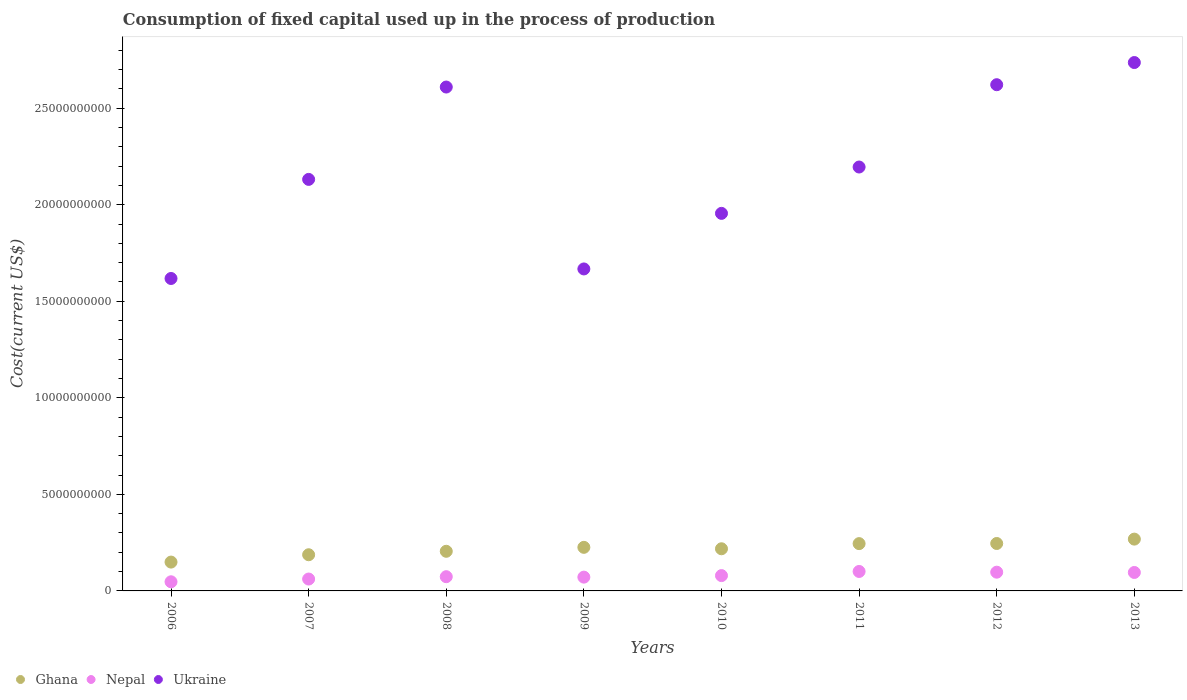What is the amount consumed in the process of production in Nepal in 2012?
Ensure brevity in your answer.  9.70e+08. Across all years, what is the maximum amount consumed in the process of production in Ukraine?
Keep it short and to the point. 2.74e+1. Across all years, what is the minimum amount consumed in the process of production in Nepal?
Keep it short and to the point. 4.73e+08. In which year was the amount consumed in the process of production in Ghana maximum?
Give a very brief answer. 2013. What is the total amount consumed in the process of production in Ghana in the graph?
Offer a very short reply. 1.74e+1. What is the difference between the amount consumed in the process of production in Ghana in 2006 and that in 2009?
Provide a short and direct response. -7.63e+08. What is the difference between the amount consumed in the process of production in Ghana in 2009 and the amount consumed in the process of production in Nepal in 2010?
Provide a short and direct response. 1.46e+09. What is the average amount consumed in the process of production in Ukraine per year?
Ensure brevity in your answer.  2.19e+1. In the year 2006, what is the difference between the amount consumed in the process of production in Ukraine and amount consumed in the process of production in Ghana?
Offer a terse response. 1.47e+1. In how many years, is the amount consumed in the process of production in Ukraine greater than 27000000000 US$?
Offer a very short reply. 1. What is the ratio of the amount consumed in the process of production in Nepal in 2007 to that in 2010?
Your answer should be compact. 0.78. What is the difference between the highest and the second highest amount consumed in the process of production in Ukraine?
Your answer should be very brief. 1.15e+09. What is the difference between the highest and the lowest amount consumed in the process of production in Nepal?
Offer a very short reply. 5.35e+08. In how many years, is the amount consumed in the process of production in Ukraine greater than the average amount consumed in the process of production in Ukraine taken over all years?
Your response must be concise. 4. Is the sum of the amount consumed in the process of production in Nepal in 2008 and 2010 greater than the maximum amount consumed in the process of production in Ukraine across all years?
Your answer should be compact. No. Is it the case that in every year, the sum of the amount consumed in the process of production in Ghana and amount consumed in the process of production in Nepal  is greater than the amount consumed in the process of production in Ukraine?
Your answer should be compact. No. Is the amount consumed in the process of production in Ghana strictly less than the amount consumed in the process of production in Ukraine over the years?
Provide a short and direct response. Yes. How many years are there in the graph?
Provide a succinct answer. 8. Does the graph contain grids?
Give a very brief answer. No. How are the legend labels stacked?
Your answer should be very brief. Horizontal. What is the title of the graph?
Your answer should be compact. Consumption of fixed capital used up in the process of production. What is the label or title of the X-axis?
Make the answer very short. Years. What is the label or title of the Y-axis?
Offer a very short reply. Cost(current US$). What is the Cost(current US$) of Ghana in 2006?
Provide a succinct answer. 1.49e+09. What is the Cost(current US$) of Nepal in 2006?
Keep it short and to the point. 4.73e+08. What is the Cost(current US$) of Ukraine in 2006?
Offer a very short reply. 1.62e+1. What is the Cost(current US$) in Ghana in 2007?
Your response must be concise. 1.87e+09. What is the Cost(current US$) in Nepal in 2007?
Keep it short and to the point. 6.16e+08. What is the Cost(current US$) in Ukraine in 2007?
Your response must be concise. 2.13e+1. What is the Cost(current US$) in Ghana in 2008?
Your response must be concise. 2.05e+09. What is the Cost(current US$) in Nepal in 2008?
Make the answer very short. 7.37e+08. What is the Cost(current US$) of Ukraine in 2008?
Give a very brief answer. 2.61e+1. What is the Cost(current US$) of Ghana in 2009?
Offer a very short reply. 2.26e+09. What is the Cost(current US$) in Nepal in 2009?
Provide a short and direct response. 7.14e+08. What is the Cost(current US$) of Ukraine in 2009?
Ensure brevity in your answer.  1.67e+1. What is the Cost(current US$) in Ghana in 2010?
Keep it short and to the point. 2.18e+09. What is the Cost(current US$) of Nepal in 2010?
Keep it short and to the point. 7.93e+08. What is the Cost(current US$) in Ukraine in 2010?
Ensure brevity in your answer.  1.96e+1. What is the Cost(current US$) of Ghana in 2011?
Give a very brief answer. 2.45e+09. What is the Cost(current US$) of Nepal in 2011?
Your response must be concise. 1.01e+09. What is the Cost(current US$) of Ukraine in 2011?
Offer a very short reply. 2.20e+1. What is the Cost(current US$) in Ghana in 2012?
Provide a succinct answer. 2.46e+09. What is the Cost(current US$) of Nepal in 2012?
Your answer should be very brief. 9.70e+08. What is the Cost(current US$) in Ukraine in 2012?
Make the answer very short. 2.62e+1. What is the Cost(current US$) of Ghana in 2013?
Give a very brief answer. 2.68e+09. What is the Cost(current US$) in Nepal in 2013?
Your answer should be very brief. 9.56e+08. What is the Cost(current US$) in Ukraine in 2013?
Provide a short and direct response. 2.74e+1. Across all years, what is the maximum Cost(current US$) in Ghana?
Provide a short and direct response. 2.68e+09. Across all years, what is the maximum Cost(current US$) in Nepal?
Ensure brevity in your answer.  1.01e+09. Across all years, what is the maximum Cost(current US$) of Ukraine?
Offer a very short reply. 2.74e+1. Across all years, what is the minimum Cost(current US$) of Ghana?
Offer a terse response. 1.49e+09. Across all years, what is the minimum Cost(current US$) of Nepal?
Make the answer very short. 4.73e+08. Across all years, what is the minimum Cost(current US$) of Ukraine?
Provide a short and direct response. 1.62e+1. What is the total Cost(current US$) in Ghana in the graph?
Make the answer very short. 1.74e+1. What is the total Cost(current US$) in Nepal in the graph?
Give a very brief answer. 6.27e+09. What is the total Cost(current US$) in Ukraine in the graph?
Provide a succinct answer. 1.75e+11. What is the difference between the Cost(current US$) of Ghana in 2006 and that in 2007?
Keep it short and to the point. -3.80e+08. What is the difference between the Cost(current US$) in Nepal in 2006 and that in 2007?
Make the answer very short. -1.43e+08. What is the difference between the Cost(current US$) of Ukraine in 2006 and that in 2007?
Your answer should be compact. -5.13e+09. What is the difference between the Cost(current US$) in Ghana in 2006 and that in 2008?
Ensure brevity in your answer.  -5.59e+08. What is the difference between the Cost(current US$) in Nepal in 2006 and that in 2008?
Your response must be concise. -2.64e+08. What is the difference between the Cost(current US$) of Ukraine in 2006 and that in 2008?
Your answer should be very brief. -9.91e+09. What is the difference between the Cost(current US$) of Ghana in 2006 and that in 2009?
Offer a very short reply. -7.63e+08. What is the difference between the Cost(current US$) of Nepal in 2006 and that in 2009?
Give a very brief answer. -2.41e+08. What is the difference between the Cost(current US$) in Ukraine in 2006 and that in 2009?
Offer a very short reply. -4.94e+08. What is the difference between the Cost(current US$) of Ghana in 2006 and that in 2010?
Provide a short and direct response. -6.89e+08. What is the difference between the Cost(current US$) in Nepal in 2006 and that in 2010?
Your answer should be very brief. -3.20e+08. What is the difference between the Cost(current US$) in Ukraine in 2006 and that in 2010?
Offer a very short reply. -3.37e+09. What is the difference between the Cost(current US$) of Ghana in 2006 and that in 2011?
Your answer should be very brief. -9.56e+08. What is the difference between the Cost(current US$) in Nepal in 2006 and that in 2011?
Give a very brief answer. -5.35e+08. What is the difference between the Cost(current US$) of Ukraine in 2006 and that in 2011?
Give a very brief answer. -5.77e+09. What is the difference between the Cost(current US$) in Ghana in 2006 and that in 2012?
Provide a succinct answer. -9.63e+08. What is the difference between the Cost(current US$) in Nepal in 2006 and that in 2012?
Offer a terse response. -4.97e+08. What is the difference between the Cost(current US$) in Ukraine in 2006 and that in 2012?
Offer a very short reply. -1.00e+1. What is the difference between the Cost(current US$) in Ghana in 2006 and that in 2013?
Give a very brief answer. -1.19e+09. What is the difference between the Cost(current US$) of Nepal in 2006 and that in 2013?
Keep it short and to the point. -4.83e+08. What is the difference between the Cost(current US$) in Ukraine in 2006 and that in 2013?
Make the answer very short. -1.12e+1. What is the difference between the Cost(current US$) of Ghana in 2007 and that in 2008?
Your answer should be compact. -1.79e+08. What is the difference between the Cost(current US$) in Nepal in 2007 and that in 2008?
Keep it short and to the point. -1.21e+08. What is the difference between the Cost(current US$) in Ukraine in 2007 and that in 2008?
Your response must be concise. -4.78e+09. What is the difference between the Cost(current US$) in Ghana in 2007 and that in 2009?
Make the answer very short. -3.84e+08. What is the difference between the Cost(current US$) of Nepal in 2007 and that in 2009?
Your answer should be very brief. -9.81e+07. What is the difference between the Cost(current US$) in Ukraine in 2007 and that in 2009?
Offer a terse response. 4.64e+09. What is the difference between the Cost(current US$) in Ghana in 2007 and that in 2010?
Your response must be concise. -3.09e+08. What is the difference between the Cost(current US$) of Nepal in 2007 and that in 2010?
Provide a short and direct response. -1.78e+08. What is the difference between the Cost(current US$) in Ukraine in 2007 and that in 2010?
Your response must be concise. 1.76e+09. What is the difference between the Cost(current US$) in Ghana in 2007 and that in 2011?
Offer a terse response. -5.76e+08. What is the difference between the Cost(current US$) in Nepal in 2007 and that in 2011?
Offer a very short reply. -3.92e+08. What is the difference between the Cost(current US$) of Ukraine in 2007 and that in 2011?
Ensure brevity in your answer.  -6.41e+08. What is the difference between the Cost(current US$) of Ghana in 2007 and that in 2012?
Keep it short and to the point. -5.83e+08. What is the difference between the Cost(current US$) in Nepal in 2007 and that in 2012?
Offer a terse response. -3.55e+08. What is the difference between the Cost(current US$) in Ukraine in 2007 and that in 2012?
Your response must be concise. -4.90e+09. What is the difference between the Cost(current US$) of Ghana in 2007 and that in 2013?
Offer a terse response. -8.10e+08. What is the difference between the Cost(current US$) in Nepal in 2007 and that in 2013?
Keep it short and to the point. -3.40e+08. What is the difference between the Cost(current US$) in Ukraine in 2007 and that in 2013?
Keep it short and to the point. -6.05e+09. What is the difference between the Cost(current US$) of Ghana in 2008 and that in 2009?
Offer a terse response. -2.05e+08. What is the difference between the Cost(current US$) of Nepal in 2008 and that in 2009?
Provide a succinct answer. 2.30e+07. What is the difference between the Cost(current US$) of Ukraine in 2008 and that in 2009?
Offer a terse response. 9.42e+09. What is the difference between the Cost(current US$) of Ghana in 2008 and that in 2010?
Offer a very short reply. -1.30e+08. What is the difference between the Cost(current US$) in Nepal in 2008 and that in 2010?
Offer a terse response. -5.67e+07. What is the difference between the Cost(current US$) of Ukraine in 2008 and that in 2010?
Offer a terse response. 6.54e+09. What is the difference between the Cost(current US$) of Ghana in 2008 and that in 2011?
Give a very brief answer. -3.97e+08. What is the difference between the Cost(current US$) of Nepal in 2008 and that in 2011?
Give a very brief answer. -2.71e+08. What is the difference between the Cost(current US$) of Ukraine in 2008 and that in 2011?
Provide a short and direct response. 4.14e+09. What is the difference between the Cost(current US$) in Ghana in 2008 and that in 2012?
Offer a terse response. -4.04e+08. What is the difference between the Cost(current US$) in Nepal in 2008 and that in 2012?
Provide a succinct answer. -2.34e+08. What is the difference between the Cost(current US$) of Ukraine in 2008 and that in 2012?
Offer a terse response. -1.21e+08. What is the difference between the Cost(current US$) in Ghana in 2008 and that in 2013?
Offer a terse response. -6.31e+08. What is the difference between the Cost(current US$) in Nepal in 2008 and that in 2013?
Provide a succinct answer. -2.19e+08. What is the difference between the Cost(current US$) of Ukraine in 2008 and that in 2013?
Your answer should be very brief. -1.27e+09. What is the difference between the Cost(current US$) of Ghana in 2009 and that in 2010?
Your answer should be very brief. 7.44e+07. What is the difference between the Cost(current US$) of Nepal in 2009 and that in 2010?
Keep it short and to the point. -7.97e+07. What is the difference between the Cost(current US$) in Ukraine in 2009 and that in 2010?
Your answer should be compact. -2.88e+09. What is the difference between the Cost(current US$) of Ghana in 2009 and that in 2011?
Your answer should be very brief. -1.93e+08. What is the difference between the Cost(current US$) in Nepal in 2009 and that in 2011?
Give a very brief answer. -2.94e+08. What is the difference between the Cost(current US$) in Ukraine in 2009 and that in 2011?
Offer a very short reply. -5.28e+09. What is the difference between the Cost(current US$) in Ghana in 2009 and that in 2012?
Your answer should be compact. -1.99e+08. What is the difference between the Cost(current US$) in Nepal in 2009 and that in 2012?
Offer a terse response. -2.57e+08. What is the difference between the Cost(current US$) of Ukraine in 2009 and that in 2012?
Your answer should be very brief. -9.54e+09. What is the difference between the Cost(current US$) in Ghana in 2009 and that in 2013?
Your response must be concise. -4.26e+08. What is the difference between the Cost(current US$) in Nepal in 2009 and that in 2013?
Keep it short and to the point. -2.42e+08. What is the difference between the Cost(current US$) in Ukraine in 2009 and that in 2013?
Make the answer very short. -1.07e+1. What is the difference between the Cost(current US$) in Ghana in 2010 and that in 2011?
Your answer should be compact. -2.67e+08. What is the difference between the Cost(current US$) in Nepal in 2010 and that in 2011?
Make the answer very short. -2.14e+08. What is the difference between the Cost(current US$) in Ukraine in 2010 and that in 2011?
Provide a short and direct response. -2.40e+09. What is the difference between the Cost(current US$) of Ghana in 2010 and that in 2012?
Make the answer very short. -2.74e+08. What is the difference between the Cost(current US$) of Nepal in 2010 and that in 2012?
Give a very brief answer. -1.77e+08. What is the difference between the Cost(current US$) of Ukraine in 2010 and that in 2012?
Your response must be concise. -6.66e+09. What is the difference between the Cost(current US$) of Ghana in 2010 and that in 2013?
Provide a succinct answer. -5.00e+08. What is the difference between the Cost(current US$) of Nepal in 2010 and that in 2013?
Provide a succinct answer. -1.62e+08. What is the difference between the Cost(current US$) of Ukraine in 2010 and that in 2013?
Keep it short and to the point. -7.81e+09. What is the difference between the Cost(current US$) in Ghana in 2011 and that in 2012?
Give a very brief answer. -6.71e+06. What is the difference between the Cost(current US$) of Nepal in 2011 and that in 2012?
Offer a terse response. 3.75e+07. What is the difference between the Cost(current US$) in Ukraine in 2011 and that in 2012?
Offer a terse response. -4.26e+09. What is the difference between the Cost(current US$) of Ghana in 2011 and that in 2013?
Provide a short and direct response. -2.33e+08. What is the difference between the Cost(current US$) of Nepal in 2011 and that in 2013?
Keep it short and to the point. 5.21e+07. What is the difference between the Cost(current US$) in Ukraine in 2011 and that in 2013?
Provide a succinct answer. -5.41e+09. What is the difference between the Cost(current US$) in Ghana in 2012 and that in 2013?
Offer a terse response. -2.27e+08. What is the difference between the Cost(current US$) of Nepal in 2012 and that in 2013?
Your answer should be very brief. 1.47e+07. What is the difference between the Cost(current US$) of Ukraine in 2012 and that in 2013?
Ensure brevity in your answer.  -1.15e+09. What is the difference between the Cost(current US$) of Ghana in 2006 and the Cost(current US$) of Nepal in 2007?
Provide a short and direct response. 8.78e+08. What is the difference between the Cost(current US$) of Ghana in 2006 and the Cost(current US$) of Ukraine in 2007?
Provide a succinct answer. -1.98e+1. What is the difference between the Cost(current US$) of Nepal in 2006 and the Cost(current US$) of Ukraine in 2007?
Ensure brevity in your answer.  -2.08e+1. What is the difference between the Cost(current US$) of Ghana in 2006 and the Cost(current US$) of Nepal in 2008?
Provide a succinct answer. 7.57e+08. What is the difference between the Cost(current US$) of Ghana in 2006 and the Cost(current US$) of Ukraine in 2008?
Make the answer very short. -2.46e+1. What is the difference between the Cost(current US$) of Nepal in 2006 and the Cost(current US$) of Ukraine in 2008?
Offer a terse response. -2.56e+1. What is the difference between the Cost(current US$) of Ghana in 2006 and the Cost(current US$) of Nepal in 2009?
Offer a terse response. 7.80e+08. What is the difference between the Cost(current US$) in Ghana in 2006 and the Cost(current US$) in Ukraine in 2009?
Keep it short and to the point. -1.52e+1. What is the difference between the Cost(current US$) in Nepal in 2006 and the Cost(current US$) in Ukraine in 2009?
Keep it short and to the point. -1.62e+1. What is the difference between the Cost(current US$) of Ghana in 2006 and the Cost(current US$) of Nepal in 2010?
Provide a succinct answer. 7.00e+08. What is the difference between the Cost(current US$) of Ghana in 2006 and the Cost(current US$) of Ukraine in 2010?
Provide a short and direct response. -1.81e+1. What is the difference between the Cost(current US$) of Nepal in 2006 and the Cost(current US$) of Ukraine in 2010?
Your answer should be compact. -1.91e+1. What is the difference between the Cost(current US$) in Ghana in 2006 and the Cost(current US$) in Nepal in 2011?
Provide a short and direct response. 4.86e+08. What is the difference between the Cost(current US$) in Ghana in 2006 and the Cost(current US$) in Ukraine in 2011?
Keep it short and to the point. -2.05e+1. What is the difference between the Cost(current US$) in Nepal in 2006 and the Cost(current US$) in Ukraine in 2011?
Provide a succinct answer. -2.15e+1. What is the difference between the Cost(current US$) of Ghana in 2006 and the Cost(current US$) of Nepal in 2012?
Give a very brief answer. 5.23e+08. What is the difference between the Cost(current US$) in Ghana in 2006 and the Cost(current US$) in Ukraine in 2012?
Give a very brief answer. -2.47e+1. What is the difference between the Cost(current US$) of Nepal in 2006 and the Cost(current US$) of Ukraine in 2012?
Keep it short and to the point. -2.57e+1. What is the difference between the Cost(current US$) of Ghana in 2006 and the Cost(current US$) of Nepal in 2013?
Make the answer very short. 5.38e+08. What is the difference between the Cost(current US$) in Ghana in 2006 and the Cost(current US$) in Ukraine in 2013?
Your answer should be very brief. -2.59e+1. What is the difference between the Cost(current US$) in Nepal in 2006 and the Cost(current US$) in Ukraine in 2013?
Keep it short and to the point. -2.69e+1. What is the difference between the Cost(current US$) in Ghana in 2007 and the Cost(current US$) in Nepal in 2008?
Ensure brevity in your answer.  1.14e+09. What is the difference between the Cost(current US$) in Ghana in 2007 and the Cost(current US$) in Ukraine in 2008?
Give a very brief answer. -2.42e+1. What is the difference between the Cost(current US$) of Nepal in 2007 and the Cost(current US$) of Ukraine in 2008?
Your answer should be very brief. -2.55e+1. What is the difference between the Cost(current US$) of Ghana in 2007 and the Cost(current US$) of Nepal in 2009?
Offer a terse response. 1.16e+09. What is the difference between the Cost(current US$) of Ghana in 2007 and the Cost(current US$) of Ukraine in 2009?
Provide a short and direct response. -1.48e+1. What is the difference between the Cost(current US$) of Nepal in 2007 and the Cost(current US$) of Ukraine in 2009?
Give a very brief answer. -1.61e+1. What is the difference between the Cost(current US$) in Ghana in 2007 and the Cost(current US$) in Nepal in 2010?
Your answer should be very brief. 1.08e+09. What is the difference between the Cost(current US$) in Ghana in 2007 and the Cost(current US$) in Ukraine in 2010?
Provide a succinct answer. -1.77e+1. What is the difference between the Cost(current US$) in Nepal in 2007 and the Cost(current US$) in Ukraine in 2010?
Provide a short and direct response. -1.89e+1. What is the difference between the Cost(current US$) in Ghana in 2007 and the Cost(current US$) in Nepal in 2011?
Your answer should be compact. 8.65e+08. What is the difference between the Cost(current US$) of Ghana in 2007 and the Cost(current US$) of Ukraine in 2011?
Provide a short and direct response. -2.01e+1. What is the difference between the Cost(current US$) in Nepal in 2007 and the Cost(current US$) in Ukraine in 2011?
Provide a short and direct response. -2.13e+1. What is the difference between the Cost(current US$) in Ghana in 2007 and the Cost(current US$) in Nepal in 2012?
Your response must be concise. 9.03e+08. What is the difference between the Cost(current US$) in Ghana in 2007 and the Cost(current US$) in Ukraine in 2012?
Make the answer very short. -2.43e+1. What is the difference between the Cost(current US$) in Nepal in 2007 and the Cost(current US$) in Ukraine in 2012?
Ensure brevity in your answer.  -2.56e+1. What is the difference between the Cost(current US$) of Ghana in 2007 and the Cost(current US$) of Nepal in 2013?
Provide a succinct answer. 9.18e+08. What is the difference between the Cost(current US$) in Ghana in 2007 and the Cost(current US$) in Ukraine in 2013?
Provide a succinct answer. -2.55e+1. What is the difference between the Cost(current US$) in Nepal in 2007 and the Cost(current US$) in Ukraine in 2013?
Keep it short and to the point. -2.67e+1. What is the difference between the Cost(current US$) of Ghana in 2008 and the Cost(current US$) of Nepal in 2009?
Provide a short and direct response. 1.34e+09. What is the difference between the Cost(current US$) in Ghana in 2008 and the Cost(current US$) in Ukraine in 2009?
Your response must be concise. -1.46e+1. What is the difference between the Cost(current US$) in Nepal in 2008 and the Cost(current US$) in Ukraine in 2009?
Make the answer very short. -1.59e+1. What is the difference between the Cost(current US$) of Ghana in 2008 and the Cost(current US$) of Nepal in 2010?
Give a very brief answer. 1.26e+09. What is the difference between the Cost(current US$) in Ghana in 2008 and the Cost(current US$) in Ukraine in 2010?
Keep it short and to the point. -1.75e+1. What is the difference between the Cost(current US$) in Nepal in 2008 and the Cost(current US$) in Ukraine in 2010?
Keep it short and to the point. -1.88e+1. What is the difference between the Cost(current US$) of Ghana in 2008 and the Cost(current US$) of Nepal in 2011?
Offer a terse response. 1.04e+09. What is the difference between the Cost(current US$) in Ghana in 2008 and the Cost(current US$) in Ukraine in 2011?
Ensure brevity in your answer.  -1.99e+1. What is the difference between the Cost(current US$) in Nepal in 2008 and the Cost(current US$) in Ukraine in 2011?
Provide a short and direct response. -2.12e+1. What is the difference between the Cost(current US$) in Ghana in 2008 and the Cost(current US$) in Nepal in 2012?
Your answer should be very brief. 1.08e+09. What is the difference between the Cost(current US$) in Ghana in 2008 and the Cost(current US$) in Ukraine in 2012?
Give a very brief answer. -2.42e+1. What is the difference between the Cost(current US$) of Nepal in 2008 and the Cost(current US$) of Ukraine in 2012?
Provide a short and direct response. -2.55e+1. What is the difference between the Cost(current US$) in Ghana in 2008 and the Cost(current US$) in Nepal in 2013?
Make the answer very short. 1.10e+09. What is the difference between the Cost(current US$) of Ghana in 2008 and the Cost(current US$) of Ukraine in 2013?
Offer a terse response. -2.53e+1. What is the difference between the Cost(current US$) in Nepal in 2008 and the Cost(current US$) in Ukraine in 2013?
Your answer should be very brief. -2.66e+1. What is the difference between the Cost(current US$) in Ghana in 2009 and the Cost(current US$) in Nepal in 2010?
Offer a terse response. 1.46e+09. What is the difference between the Cost(current US$) in Ghana in 2009 and the Cost(current US$) in Ukraine in 2010?
Your answer should be compact. -1.73e+1. What is the difference between the Cost(current US$) in Nepal in 2009 and the Cost(current US$) in Ukraine in 2010?
Keep it short and to the point. -1.88e+1. What is the difference between the Cost(current US$) in Ghana in 2009 and the Cost(current US$) in Nepal in 2011?
Provide a succinct answer. 1.25e+09. What is the difference between the Cost(current US$) in Ghana in 2009 and the Cost(current US$) in Ukraine in 2011?
Keep it short and to the point. -1.97e+1. What is the difference between the Cost(current US$) of Nepal in 2009 and the Cost(current US$) of Ukraine in 2011?
Provide a short and direct response. -2.12e+1. What is the difference between the Cost(current US$) in Ghana in 2009 and the Cost(current US$) in Nepal in 2012?
Give a very brief answer. 1.29e+09. What is the difference between the Cost(current US$) of Ghana in 2009 and the Cost(current US$) of Ukraine in 2012?
Offer a very short reply. -2.40e+1. What is the difference between the Cost(current US$) of Nepal in 2009 and the Cost(current US$) of Ukraine in 2012?
Provide a succinct answer. -2.55e+1. What is the difference between the Cost(current US$) in Ghana in 2009 and the Cost(current US$) in Nepal in 2013?
Your response must be concise. 1.30e+09. What is the difference between the Cost(current US$) in Ghana in 2009 and the Cost(current US$) in Ukraine in 2013?
Offer a terse response. -2.51e+1. What is the difference between the Cost(current US$) in Nepal in 2009 and the Cost(current US$) in Ukraine in 2013?
Ensure brevity in your answer.  -2.66e+1. What is the difference between the Cost(current US$) of Ghana in 2010 and the Cost(current US$) of Nepal in 2011?
Make the answer very short. 1.17e+09. What is the difference between the Cost(current US$) of Ghana in 2010 and the Cost(current US$) of Ukraine in 2011?
Your answer should be very brief. -1.98e+1. What is the difference between the Cost(current US$) in Nepal in 2010 and the Cost(current US$) in Ukraine in 2011?
Offer a very short reply. -2.12e+1. What is the difference between the Cost(current US$) in Ghana in 2010 and the Cost(current US$) in Nepal in 2012?
Give a very brief answer. 1.21e+09. What is the difference between the Cost(current US$) in Ghana in 2010 and the Cost(current US$) in Ukraine in 2012?
Offer a terse response. -2.40e+1. What is the difference between the Cost(current US$) in Nepal in 2010 and the Cost(current US$) in Ukraine in 2012?
Offer a terse response. -2.54e+1. What is the difference between the Cost(current US$) in Ghana in 2010 and the Cost(current US$) in Nepal in 2013?
Give a very brief answer. 1.23e+09. What is the difference between the Cost(current US$) in Ghana in 2010 and the Cost(current US$) in Ukraine in 2013?
Offer a terse response. -2.52e+1. What is the difference between the Cost(current US$) in Nepal in 2010 and the Cost(current US$) in Ukraine in 2013?
Your answer should be very brief. -2.66e+1. What is the difference between the Cost(current US$) in Ghana in 2011 and the Cost(current US$) in Nepal in 2012?
Provide a succinct answer. 1.48e+09. What is the difference between the Cost(current US$) in Ghana in 2011 and the Cost(current US$) in Ukraine in 2012?
Provide a succinct answer. -2.38e+1. What is the difference between the Cost(current US$) in Nepal in 2011 and the Cost(current US$) in Ukraine in 2012?
Ensure brevity in your answer.  -2.52e+1. What is the difference between the Cost(current US$) of Ghana in 2011 and the Cost(current US$) of Nepal in 2013?
Your answer should be compact. 1.49e+09. What is the difference between the Cost(current US$) in Ghana in 2011 and the Cost(current US$) in Ukraine in 2013?
Offer a terse response. -2.49e+1. What is the difference between the Cost(current US$) in Nepal in 2011 and the Cost(current US$) in Ukraine in 2013?
Your answer should be very brief. -2.64e+1. What is the difference between the Cost(current US$) in Ghana in 2012 and the Cost(current US$) in Nepal in 2013?
Your answer should be compact. 1.50e+09. What is the difference between the Cost(current US$) in Ghana in 2012 and the Cost(current US$) in Ukraine in 2013?
Provide a succinct answer. -2.49e+1. What is the difference between the Cost(current US$) of Nepal in 2012 and the Cost(current US$) of Ukraine in 2013?
Your response must be concise. -2.64e+1. What is the average Cost(current US$) in Ghana per year?
Your answer should be compact. 2.18e+09. What is the average Cost(current US$) in Nepal per year?
Ensure brevity in your answer.  7.83e+08. What is the average Cost(current US$) of Ukraine per year?
Keep it short and to the point. 2.19e+1. In the year 2006, what is the difference between the Cost(current US$) of Ghana and Cost(current US$) of Nepal?
Keep it short and to the point. 1.02e+09. In the year 2006, what is the difference between the Cost(current US$) in Ghana and Cost(current US$) in Ukraine?
Your response must be concise. -1.47e+1. In the year 2006, what is the difference between the Cost(current US$) of Nepal and Cost(current US$) of Ukraine?
Offer a very short reply. -1.57e+1. In the year 2007, what is the difference between the Cost(current US$) of Ghana and Cost(current US$) of Nepal?
Your answer should be compact. 1.26e+09. In the year 2007, what is the difference between the Cost(current US$) in Ghana and Cost(current US$) in Ukraine?
Keep it short and to the point. -1.94e+1. In the year 2007, what is the difference between the Cost(current US$) of Nepal and Cost(current US$) of Ukraine?
Keep it short and to the point. -2.07e+1. In the year 2008, what is the difference between the Cost(current US$) in Ghana and Cost(current US$) in Nepal?
Give a very brief answer. 1.32e+09. In the year 2008, what is the difference between the Cost(current US$) of Ghana and Cost(current US$) of Ukraine?
Provide a succinct answer. -2.40e+1. In the year 2008, what is the difference between the Cost(current US$) of Nepal and Cost(current US$) of Ukraine?
Make the answer very short. -2.54e+1. In the year 2009, what is the difference between the Cost(current US$) in Ghana and Cost(current US$) in Nepal?
Provide a succinct answer. 1.54e+09. In the year 2009, what is the difference between the Cost(current US$) in Ghana and Cost(current US$) in Ukraine?
Make the answer very short. -1.44e+1. In the year 2009, what is the difference between the Cost(current US$) of Nepal and Cost(current US$) of Ukraine?
Give a very brief answer. -1.60e+1. In the year 2010, what is the difference between the Cost(current US$) in Ghana and Cost(current US$) in Nepal?
Your response must be concise. 1.39e+09. In the year 2010, what is the difference between the Cost(current US$) of Ghana and Cost(current US$) of Ukraine?
Provide a succinct answer. -1.74e+1. In the year 2010, what is the difference between the Cost(current US$) in Nepal and Cost(current US$) in Ukraine?
Your response must be concise. -1.88e+1. In the year 2011, what is the difference between the Cost(current US$) of Ghana and Cost(current US$) of Nepal?
Offer a very short reply. 1.44e+09. In the year 2011, what is the difference between the Cost(current US$) in Ghana and Cost(current US$) in Ukraine?
Keep it short and to the point. -1.95e+1. In the year 2011, what is the difference between the Cost(current US$) in Nepal and Cost(current US$) in Ukraine?
Give a very brief answer. -2.09e+1. In the year 2012, what is the difference between the Cost(current US$) of Ghana and Cost(current US$) of Nepal?
Offer a very short reply. 1.49e+09. In the year 2012, what is the difference between the Cost(current US$) of Ghana and Cost(current US$) of Ukraine?
Your response must be concise. -2.38e+1. In the year 2012, what is the difference between the Cost(current US$) in Nepal and Cost(current US$) in Ukraine?
Provide a short and direct response. -2.52e+1. In the year 2013, what is the difference between the Cost(current US$) of Ghana and Cost(current US$) of Nepal?
Give a very brief answer. 1.73e+09. In the year 2013, what is the difference between the Cost(current US$) of Ghana and Cost(current US$) of Ukraine?
Provide a succinct answer. -2.47e+1. In the year 2013, what is the difference between the Cost(current US$) of Nepal and Cost(current US$) of Ukraine?
Keep it short and to the point. -2.64e+1. What is the ratio of the Cost(current US$) in Ghana in 2006 to that in 2007?
Your response must be concise. 0.8. What is the ratio of the Cost(current US$) in Nepal in 2006 to that in 2007?
Give a very brief answer. 0.77. What is the ratio of the Cost(current US$) of Ukraine in 2006 to that in 2007?
Your answer should be compact. 0.76. What is the ratio of the Cost(current US$) of Ghana in 2006 to that in 2008?
Give a very brief answer. 0.73. What is the ratio of the Cost(current US$) of Nepal in 2006 to that in 2008?
Provide a succinct answer. 0.64. What is the ratio of the Cost(current US$) of Ukraine in 2006 to that in 2008?
Your response must be concise. 0.62. What is the ratio of the Cost(current US$) of Ghana in 2006 to that in 2009?
Provide a succinct answer. 0.66. What is the ratio of the Cost(current US$) of Nepal in 2006 to that in 2009?
Provide a short and direct response. 0.66. What is the ratio of the Cost(current US$) in Ukraine in 2006 to that in 2009?
Your answer should be very brief. 0.97. What is the ratio of the Cost(current US$) in Ghana in 2006 to that in 2010?
Your response must be concise. 0.68. What is the ratio of the Cost(current US$) of Nepal in 2006 to that in 2010?
Your answer should be compact. 0.6. What is the ratio of the Cost(current US$) of Ukraine in 2006 to that in 2010?
Make the answer very short. 0.83. What is the ratio of the Cost(current US$) of Ghana in 2006 to that in 2011?
Your answer should be compact. 0.61. What is the ratio of the Cost(current US$) of Nepal in 2006 to that in 2011?
Your answer should be compact. 0.47. What is the ratio of the Cost(current US$) in Ukraine in 2006 to that in 2011?
Provide a short and direct response. 0.74. What is the ratio of the Cost(current US$) in Ghana in 2006 to that in 2012?
Give a very brief answer. 0.61. What is the ratio of the Cost(current US$) of Nepal in 2006 to that in 2012?
Offer a terse response. 0.49. What is the ratio of the Cost(current US$) in Ukraine in 2006 to that in 2012?
Provide a succinct answer. 0.62. What is the ratio of the Cost(current US$) in Ghana in 2006 to that in 2013?
Offer a terse response. 0.56. What is the ratio of the Cost(current US$) of Nepal in 2006 to that in 2013?
Offer a very short reply. 0.49. What is the ratio of the Cost(current US$) of Ukraine in 2006 to that in 2013?
Give a very brief answer. 0.59. What is the ratio of the Cost(current US$) in Ghana in 2007 to that in 2008?
Your answer should be compact. 0.91. What is the ratio of the Cost(current US$) in Nepal in 2007 to that in 2008?
Your answer should be very brief. 0.84. What is the ratio of the Cost(current US$) of Ukraine in 2007 to that in 2008?
Give a very brief answer. 0.82. What is the ratio of the Cost(current US$) of Ghana in 2007 to that in 2009?
Provide a succinct answer. 0.83. What is the ratio of the Cost(current US$) in Nepal in 2007 to that in 2009?
Give a very brief answer. 0.86. What is the ratio of the Cost(current US$) of Ukraine in 2007 to that in 2009?
Your response must be concise. 1.28. What is the ratio of the Cost(current US$) in Ghana in 2007 to that in 2010?
Ensure brevity in your answer.  0.86. What is the ratio of the Cost(current US$) in Nepal in 2007 to that in 2010?
Provide a succinct answer. 0.78. What is the ratio of the Cost(current US$) in Ukraine in 2007 to that in 2010?
Your answer should be very brief. 1.09. What is the ratio of the Cost(current US$) of Ghana in 2007 to that in 2011?
Offer a very short reply. 0.76. What is the ratio of the Cost(current US$) in Nepal in 2007 to that in 2011?
Provide a short and direct response. 0.61. What is the ratio of the Cost(current US$) of Ukraine in 2007 to that in 2011?
Keep it short and to the point. 0.97. What is the ratio of the Cost(current US$) in Ghana in 2007 to that in 2012?
Provide a succinct answer. 0.76. What is the ratio of the Cost(current US$) of Nepal in 2007 to that in 2012?
Your response must be concise. 0.63. What is the ratio of the Cost(current US$) of Ukraine in 2007 to that in 2012?
Make the answer very short. 0.81. What is the ratio of the Cost(current US$) in Ghana in 2007 to that in 2013?
Make the answer very short. 0.7. What is the ratio of the Cost(current US$) in Nepal in 2007 to that in 2013?
Ensure brevity in your answer.  0.64. What is the ratio of the Cost(current US$) in Ukraine in 2007 to that in 2013?
Give a very brief answer. 0.78. What is the ratio of the Cost(current US$) of Ghana in 2008 to that in 2009?
Keep it short and to the point. 0.91. What is the ratio of the Cost(current US$) of Nepal in 2008 to that in 2009?
Provide a succinct answer. 1.03. What is the ratio of the Cost(current US$) of Ukraine in 2008 to that in 2009?
Ensure brevity in your answer.  1.56. What is the ratio of the Cost(current US$) in Ghana in 2008 to that in 2010?
Your answer should be compact. 0.94. What is the ratio of the Cost(current US$) in Ukraine in 2008 to that in 2010?
Make the answer very short. 1.33. What is the ratio of the Cost(current US$) of Ghana in 2008 to that in 2011?
Ensure brevity in your answer.  0.84. What is the ratio of the Cost(current US$) in Nepal in 2008 to that in 2011?
Provide a short and direct response. 0.73. What is the ratio of the Cost(current US$) of Ukraine in 2008 to that in 2011?
Ensure brevity in your answer.  1.19. What is the ratio of the Cost(current US$) of Ghana in 2008 to that in 2012?
Make the answer very short. 0.84. What is the ratio of the Cost(current US$) of Nepal in 2008 to that in 2012?
Provide a short and direct response. 0.76. What is the ratio of the Cost(current US$) of Ukraine in 2008 to that in 2012?
Your response must be concise. 1. What is the ratio of the Cost(current US$) in Ghana in 2008 to that in 2013?
Your answer should be very brief. 0.76. What is the ratio of the Cost(current US$) of Nepal in 2008 to that in 2013?
Your response must be concise. 0.77. What is the ratio of the Cost(current US$) in Ukraine in 2008 to that in 2013?
Your answer should be very brief. 0.95. What is the ratio of the Cost(current US$) of Ghana in 2009 to that in 2010?
Provide a short and direct response. 1.03. What is the ratio of the Cost(current US$) in Nepal in 2009 to that in 2010?
Your response must be concise. 0.9. What is the ratio of the Cost(current US$) in Ukraine in 2009 to that in 2010?
Offer a terse response. 0.85. What is the ratio of the Cost(current US$) in Ghana in 2009 to that in 2011?
Your answer should be compact. 0.92. What is the ratio of the Cost(current US$) of Nepal in 2009 to that in 2011?
Ensure brevity in your answer.  0.71. What is the ratio of the Cost(current US$) of Ukraine in 2009 to that in 2011?
Keep it short and to the point. 0.76. What is the ratio of the Cost(current US$) in Ghana in 2009 to that in 2012?
Offer a very short reply. 0.92. What is the ratio of the Cost(current US$) of Nepal in 2009 to that in 2012?
Provide a succinct answer. 0.74. What is the ratio of the Cost(current US$) in Ukraine in 2009 to that in 2012?
Your answer should be compact. 0.64. What is the ratio of the Cost(current US$) in Ghana in 2009 to that in 2013?
Provide a succinct answer. 0.84. What is the ratio of the Cost(current US$) of Nepal in 2009 to that in 2013?
Give a very brief answer. 0.75. What is the ratio of the Cost(current US$) of Ukraine in 2009 to that in 2013?
Offer a terse response. 0.61. What is the ratio of the Cost(current US$) in Ghana in 2010 to that in 2011?
Give a very brief answer. 0.89. What is the ratio of the Cost(current US$) in Nepal in 2010 to that in 2011?
Provide a succinct answer. 0.79. What is the ratio of the Cost(current US$) of Ukraine in 2010 to that in 2011?
Give a very brief answer. 0.89. What is the ratio of the Cost(current US$) of Ghana in 2010 to that in 2012?
Ensure brevity in your answer.  0.89. What is the ratio of the Cost(current US$) in Nepal in 2010 to that in 2012?
Ensure brevity in your answer.  0.82. What is the ratio of the Cost(current US$) of Ukraine in 2010 to that in 2012?
Your response must be concise. 0.75. What is the ratio of the Cost(current US$) in Ghana in 2010 to that in 2013?
Give a very brief answer. 0.81. What is the ratio of the Cost(current US$) of Nepal in 2010 to that in 2013?
Ensure brevity in your answer.  0.83. What is the ratio of the Cost(current US$) in Ukraine in 2010 to that in 2013?
Your answer should be compact. 0.71. What is the ratio of the Cost(current US$) in Ghana in 2011 to that in 2012?
Your response must be concise. 1. What is the ratio of the Cost(current US$) in Nepal in 2011 to that in 2012?
Provide a short and direct response. 1.04. What is the ratio of the Cost(current US$) in Ukraine in 2011 to that in 2012?
Your answer should be compact. 0.84. What is the ratio of the Cost(current US$) of Ghana in 2011 to that in 2013?
Ensure brevity in your answer.  0.91. What is the ratio of the Cost(current US$) in Nepal in 2011 to that in 2013?
Your response must be concise. 1.05. What is the ratio of the Cost(current US$) in Ukraine in 2011 to that in 2013?
Your answer should be compact. 0.8. What is the ratio of the Cost(current US$) in Ghana in 2012 to that in 2013?
Your response must be concise. 0.92. What is the ratio of the Cost(current US$) of Nepal in 2012 to that in 2013?
Provide a succinct answer. 1.02. What is the ratio of the Cost(current US$) in Ukraine in 2012 to that in 2013?
Provide a short and direct response. 0.96. What is the difference between the highest and the second highest Cost(current US$) of Ghana?
Provide a short and direct response. 2.27e+08. What is the difference between the highest and the second highest Cost(current US$) of Nepal?
Your response must be concise. 3.75e+07. What is the difference between the highest and the second highest Cost(current US$) in Ukraine?
Provide a succinct answer. 1.15e+09. What is the difference between the highest and the lowest Cost(current US$) in Ghana?
Keep it short and to the point. 1.19e+09. What is the difference between the highest and the lowest Cost(current US$) of Nepal?
Provide a short and direct response. 5.35e+08. What is the difference between the highest and the lowest Cost(current US$) of Ukraine?
Offer a terse response. 1.12e+1. 